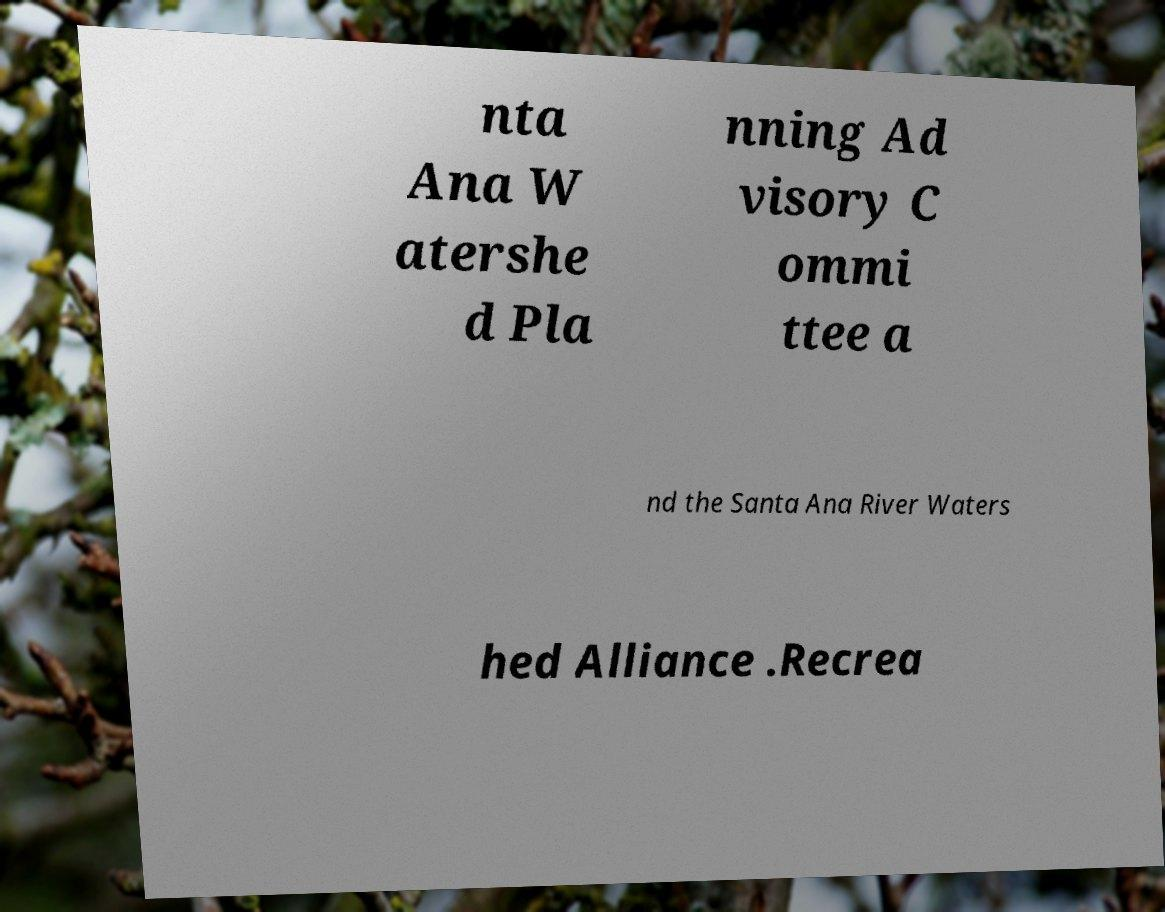Could you extract and type out the text from this image? nta Ana W atershe d Pla nning Ad visory C ommi ttee a nd the Santa Ana River Waters hed Alliance .Recrea 